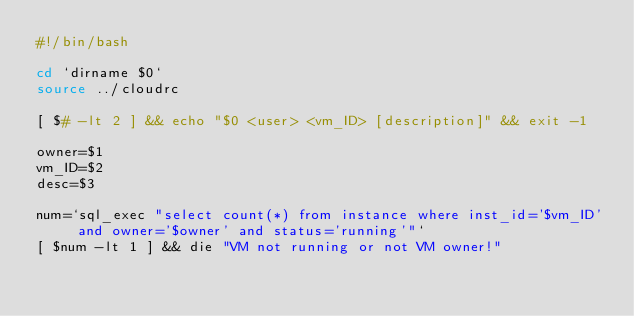<code> <loc_0><loc_0><loc_500><loc_500><_Bash_>#!/bin/bash

cd `dirname $0`
source ../cloudrc

[ $# -lt 2 ] && echo "$0 <user> <vm_ID> [description]" && exit -1

owner=$1
vm_ID=$2
desc=$3

num=`sql_exec "select count(*) from instance where inst_id='$vm_ID' and owner='$owner' and status='running'"`
[ $num -lt 1 ] && die "VM not running or not VM owner!"</code> 